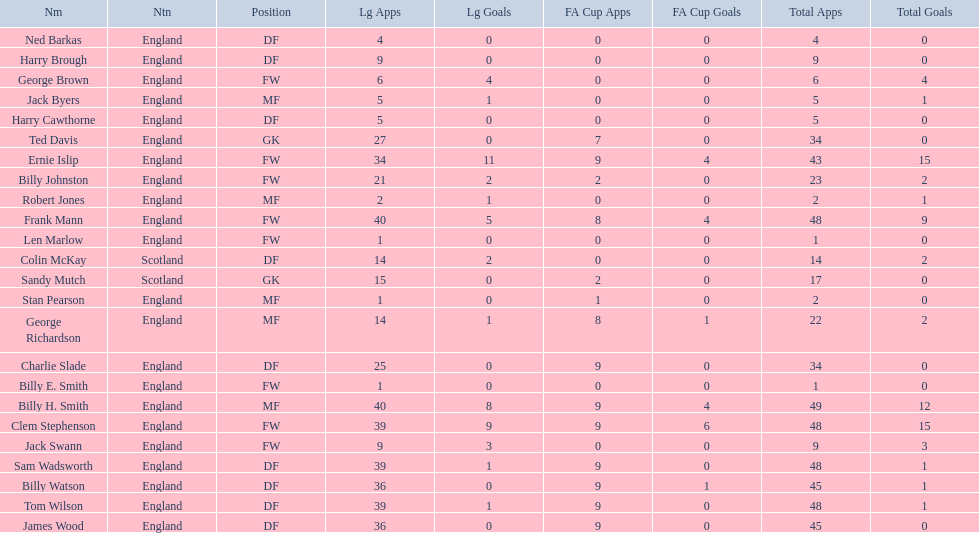Which position is listed the least amount of times on this chart? GK. Can you give me this table as a dict? {'header': ['Nm', 'Ntn', 'Position', 'Lg Apps', 'Lg Goals', 'FA Cup Apps', 'FA Cup Goals', 'Total Apps', 'Total Goals'], 'rows': [['Ned Barkas', 'England', 'DF', '4', '0', '0', '0', '4', '0'], ['Harry Brough', 'England', 'DF', '9', '0', '0', '0', '9', '0'], ['George Brown', 'England', 'FW', '6', '4', '0', '0', '6', '4'], ['Jack Byers', 'England', 'MF', '5', '1', '0', '0', '5', '1'], ['Harry Cawthorne', 'England', 'DF', '5', '0', '0', '0', '5', '0'], ['Ted Davis', 'England', 'GK', '27', '0', '7', '0', '34', '0'], ['Ernie Islip', 'England', 'FW', '34', '11', '9', '4', '43', '15'], ['Billy Johnston', 'England', 'FW', '21', '2', '2', '0', '23', '2'], ['Robert Jones', 'England', 'MF', '2', '1', '0', '0', '2', '1'], ['Frank Mann', 'England', 'FW', '40', '5', '8', '4', '48', '9'], ['Len Marlow', 'England', 'FW', '1', '0', '0', '0', '1', '0'], ['Colin McKay', 'Scotland', 'DF', '14', '2', '0', '0', '14', '2'], ['Sandy Mutch', 'Scotland', 'GK', '15', '0', '2', '0', '17', '0'], ['Stan Pearson', 'England', 'MF', '1', '0', '1', '0', '2', '0'], ['George Richardson', 'England', 'MF', '14', '1', '8', '1', '22', '2'], ['Charlie Slade', 'England', 'DF', '25', '0', '9', '0', '34', '0'], ['Billy E. Smith', 'England', 'FW', '1', '0', '0', '0', '1', '0'], ['Billy H. Smith', 'England', 'MF', '40', '8', '9', '4', '49', '12'], ['Clem Stephenson', 'England', 'FW', '39', '9', '9', '6', '48', '15'], ['Jack Swann', 'England', 'FW', '9', '3', '0', '0', '9', '3'], ['Sam Wadsworth', 'England', 'DF', '39', '1', '9', '0', '48', '1'], ['Billy Watson', 'England', 'DF', '36', '0', '9', '1', '45', '1'], ['Tom Wilson', 'England', 'DF', '39', '1', '9', '0', '48', '1'], ['James Wood', 'England', 'DF', '36', '0', '9', '0', '45', '0']]} 